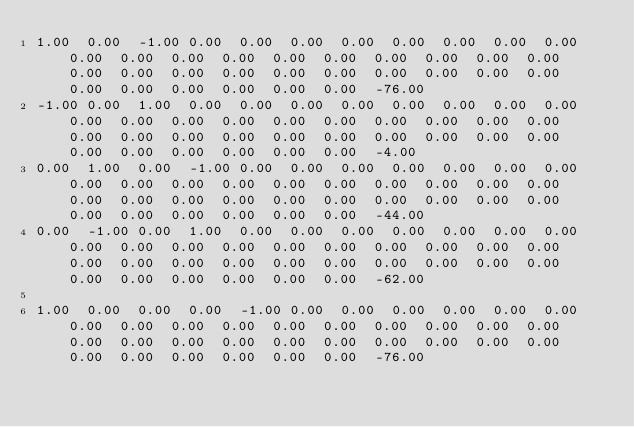<code> <loc_0><loc_0><loc_500><loc_500><_Matlab_>1.00	0.00	-1.00	0.00	0.00	0.00	0.00	0.00	0.00	0.00	0.00	0.00	0.00	0.00	0.00	0.00	0.00	0.00	0.00	0.00	0.00	0.00	0.00	0.00	0.00	0.00	0.00	0.00	0.00	0.00	0.00	0.00	0.00	0.00	0.00	0.00	0.00	-76.00
-1.00	0.00	1.00	0.00	0.00	0.00	0.00	0.00	0.00	0.00	0.00	0.00	0.00	0.00	0.00	0.00	0.00	0.00	0.00	0.00	0.00	0.00	0.00	0.00	0.00	0.00	0.00	0.00	0.00	0.00	0.00	0.00	0.00	0.00	0.00	0.00	0.00	-4.00
0.00	1.00	0.00	-1.00	0.00	0.00	0.00	0.00	0.00	0.00	0.00	0.00	0.00	0.00	0.00	0.00	0.00	0.00	0.00	0.00	0.00	0.00	0.00	0.00	0.00	0.00	0.00	0.00	0.00	0.00	0.00	0.00	0.00	0.00	0.00	0.00	0.00	-44.00
0.00	-1.00	0.00	1.00	0.00	0.00	0.00	0.00	0.00	0.00	0.00	0.00	0.00	0.00	0.00	0.00	0.00	0.00	0.00	0.00	0.00	0.00	0.00	0.00	0.00	0.00	0.00	0.00	0.00	0.00	0.00	0.00	0.00	0.00	0.00	0.00	0.00	-62.00

1.00	0.00	0.00	0.00	-1.00	0.00	0.00	0.00	0.00	0.00	0.00	0.00	0.00	0.00	0.00	0.00	0.00	0.00	0.00	0.00	0.00	0.00	0.00	0.00	0.00	0.00	0.00	0.00	0.00	0.00	0.00	0.00	0.00	0.00	0.00	0.00	0.00	-76.00</code> 